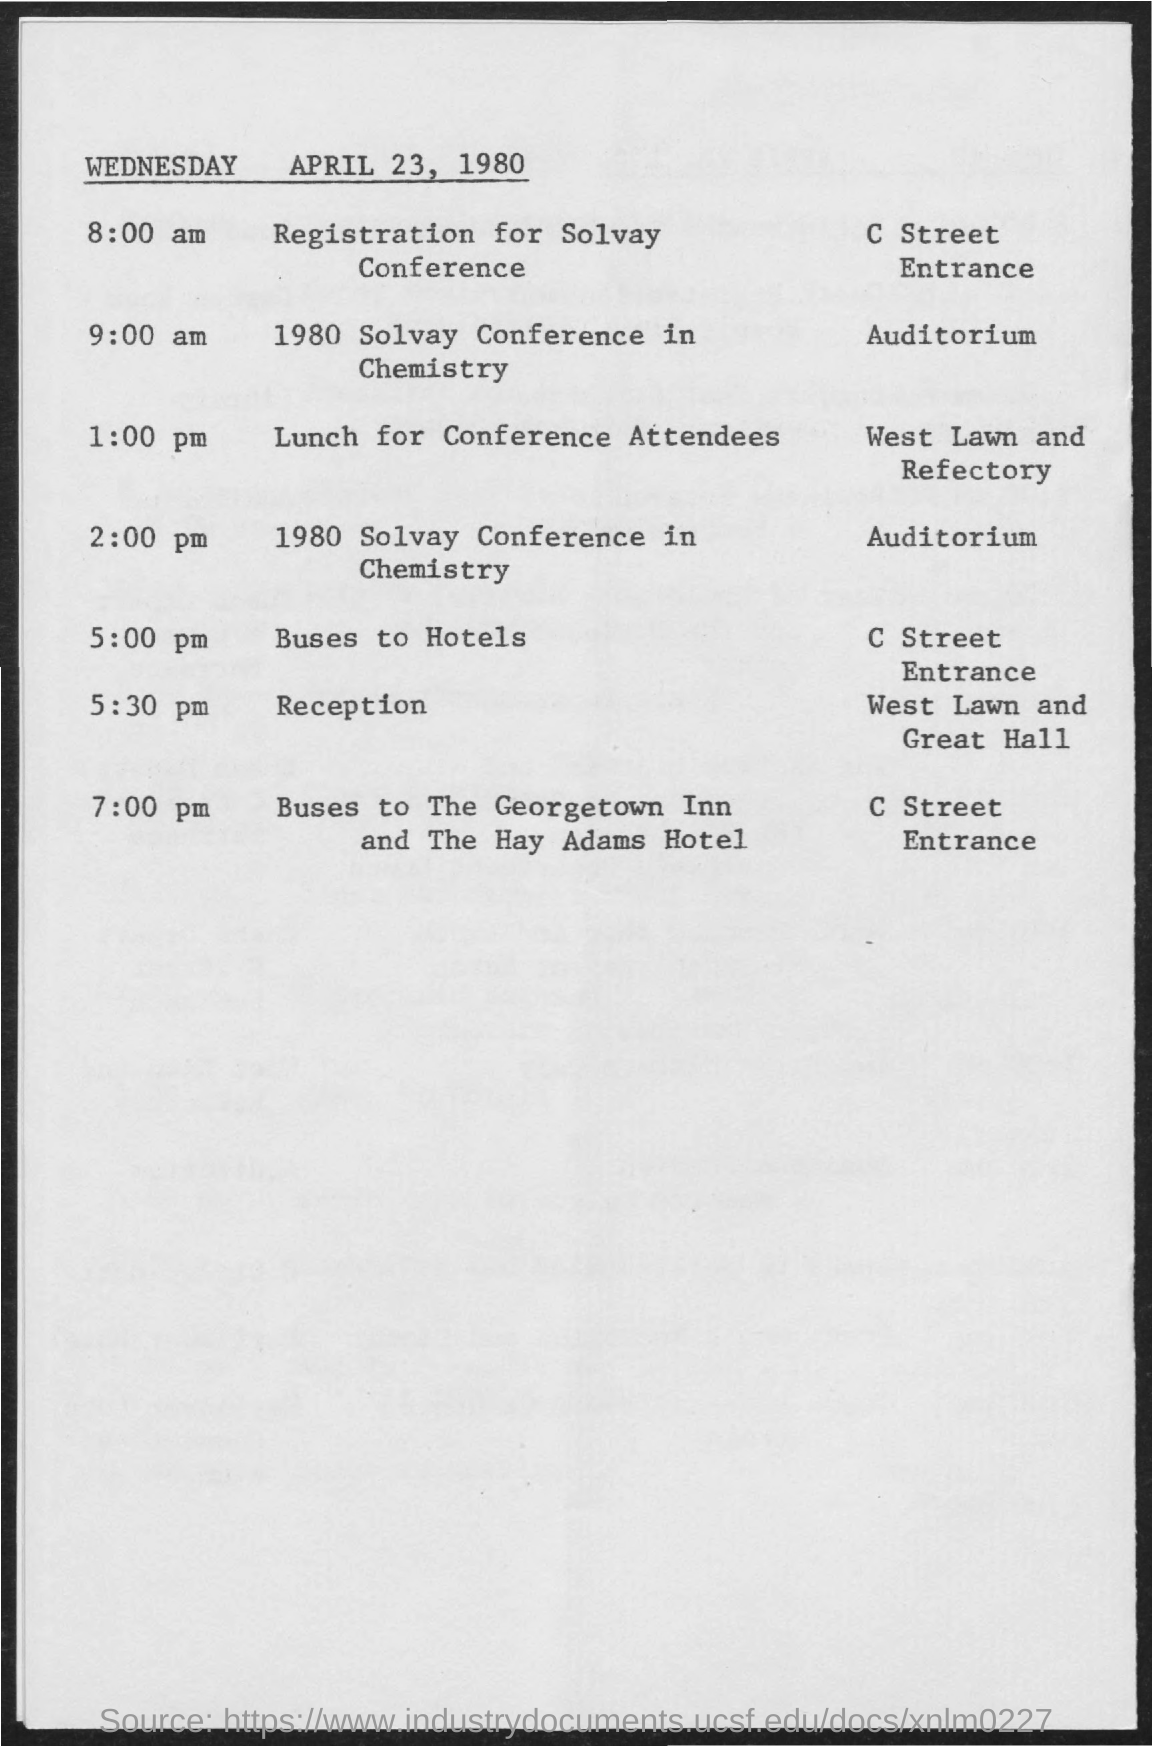Mention a couple of crucial points in this snapshot. The Solvay Conference in Chemistry was held at the Auditorium. 